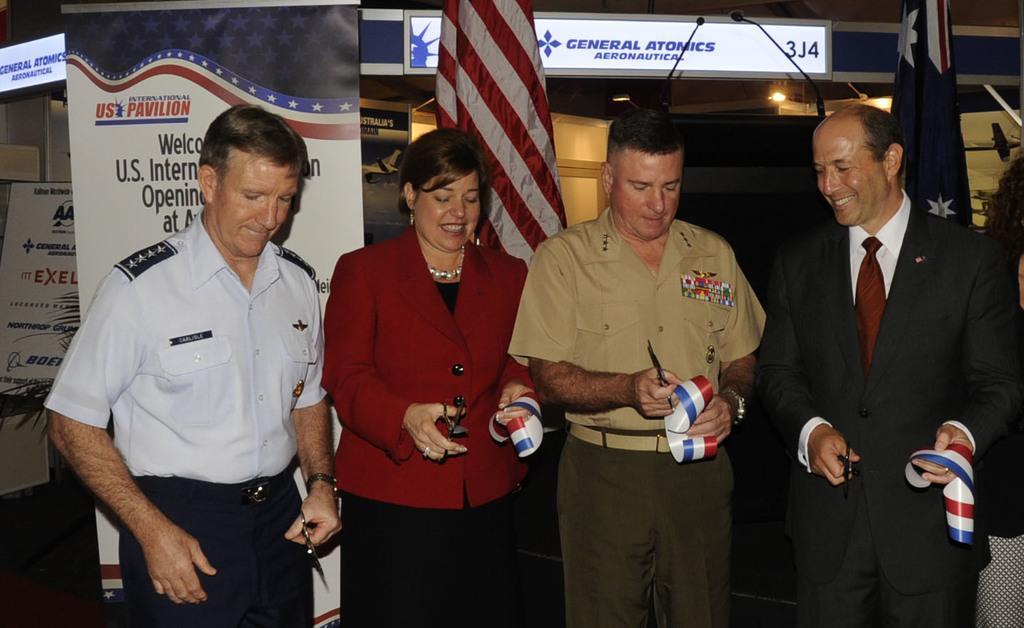Please provide a concise description of this image. This image is taken indoors. In the middle of the image a woman and three men are standing on the floor and they are holding ribbons and scissors in their hands. In the background there are many boards with text on them and there is a flag. 